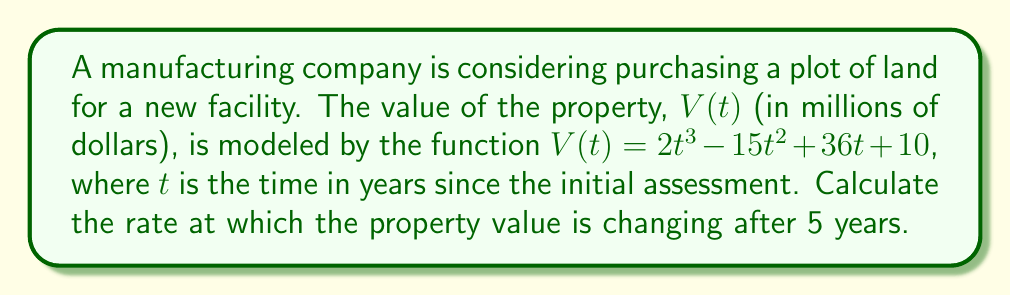Solve this math problem. To solve this problem, we need to find the derivative of the given function and evaluate it at $t = 5$. This will give us the instantaneous rate of change of the property value after 5 years.

1. Given function: $V(t) = 2t^3 - 15t^2 + 36t + 10$

2. To find the rate of change, we need to calculate $\frac{dV}{dt}$:
   $$\frac{dV}{dt} = \frac{d}{dt}(2t^3 - 15t^2 + 36t + 10)$$

3. Using the power rule and constant rule of differentiation:
   $$\frac{dV}{dt} = 6t^2 - 30t + 36$$

4. Now, we evaluate this derivative at $t = 5$:
   $$\frac{dV}{dt}\bigg|_{t=5} = 6(5)^2 - 30(5) + 36$$

5. Simplify:
   $$\frac{dV}{dt}\bigg|_{t=5} = 6(25) - 150 + 36$$
   $$\frac{dV}{dt}\bigg|_{t=5} = 150 - 150 + 36 = 36$$

The rate of change is 36 million dollars per year after 5 years.
Answer: $36$ million dollars per year 